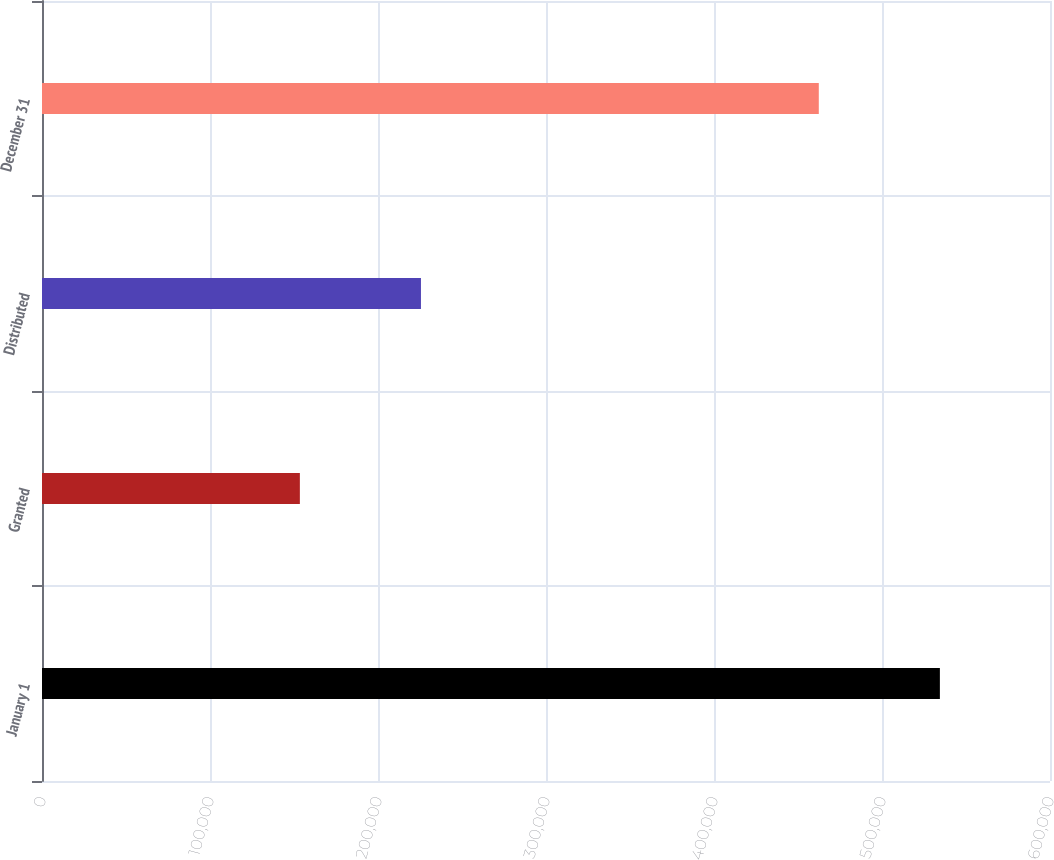<chart> <loc_0><loc_0><loc_500><loc_500><bar_chart><fcel>January 1<fcel>Granted<fcel>Distributed<fcel>December 31<nl><fcel>534456<fcel>153492<fcel>225567<fcel>462381<nl></chart> 